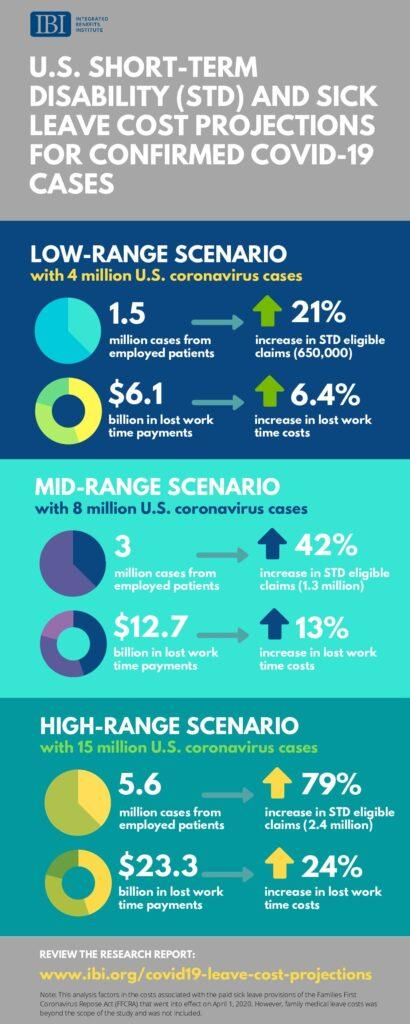Identify some key points in this picture. In the mid-range scenario, the number of employed patients is approximately 1.5 times higher than in the low-range scenario. This infographic contains three scenarios. The difference in employed patients between the high-range and mid-range scenarios is 2.6. 